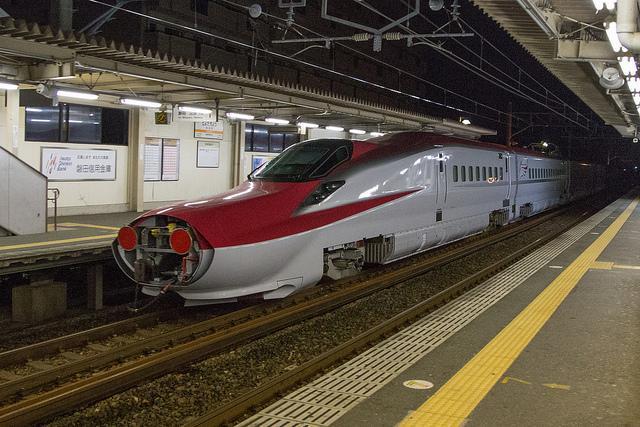How many tracks can be seen?
Give a very brief answer. 1. 